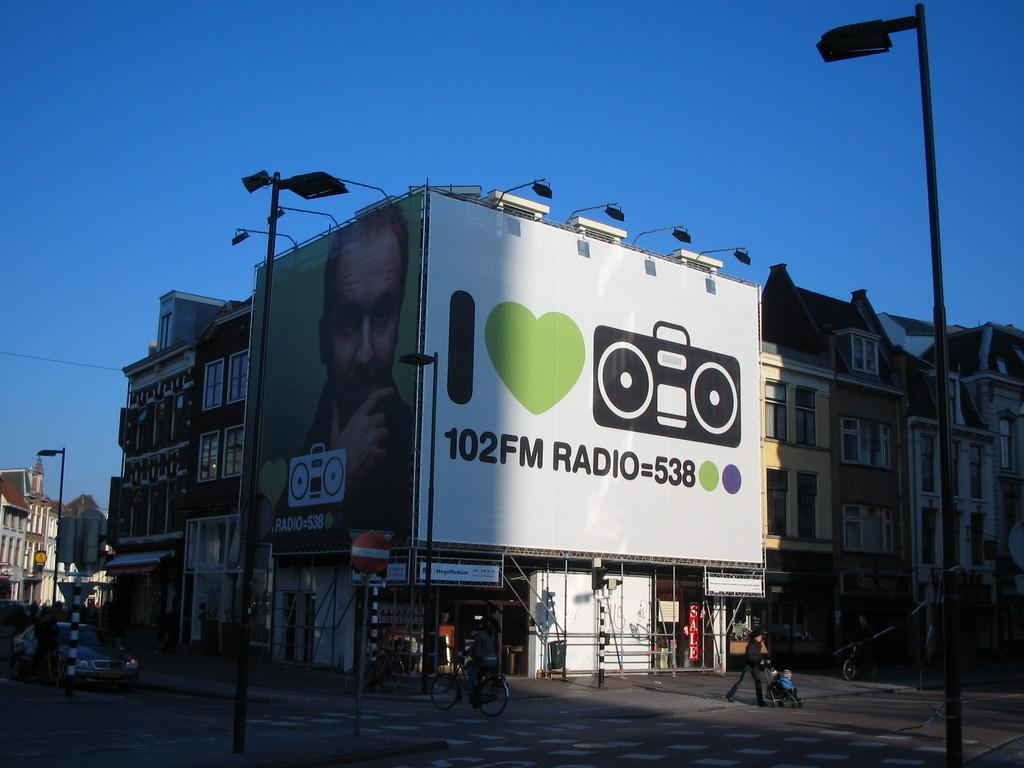<image>
Render a clear and concise summary of the photo. outside billboard of a radio station that says I love radio 102FM Radio = 538. 